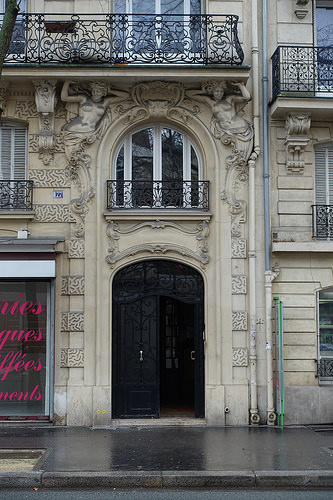<image>
Can you confirm if the door is in front of the window? No. The door is not in front of the window. The spatial positioning shows a different relationship between these objects. 